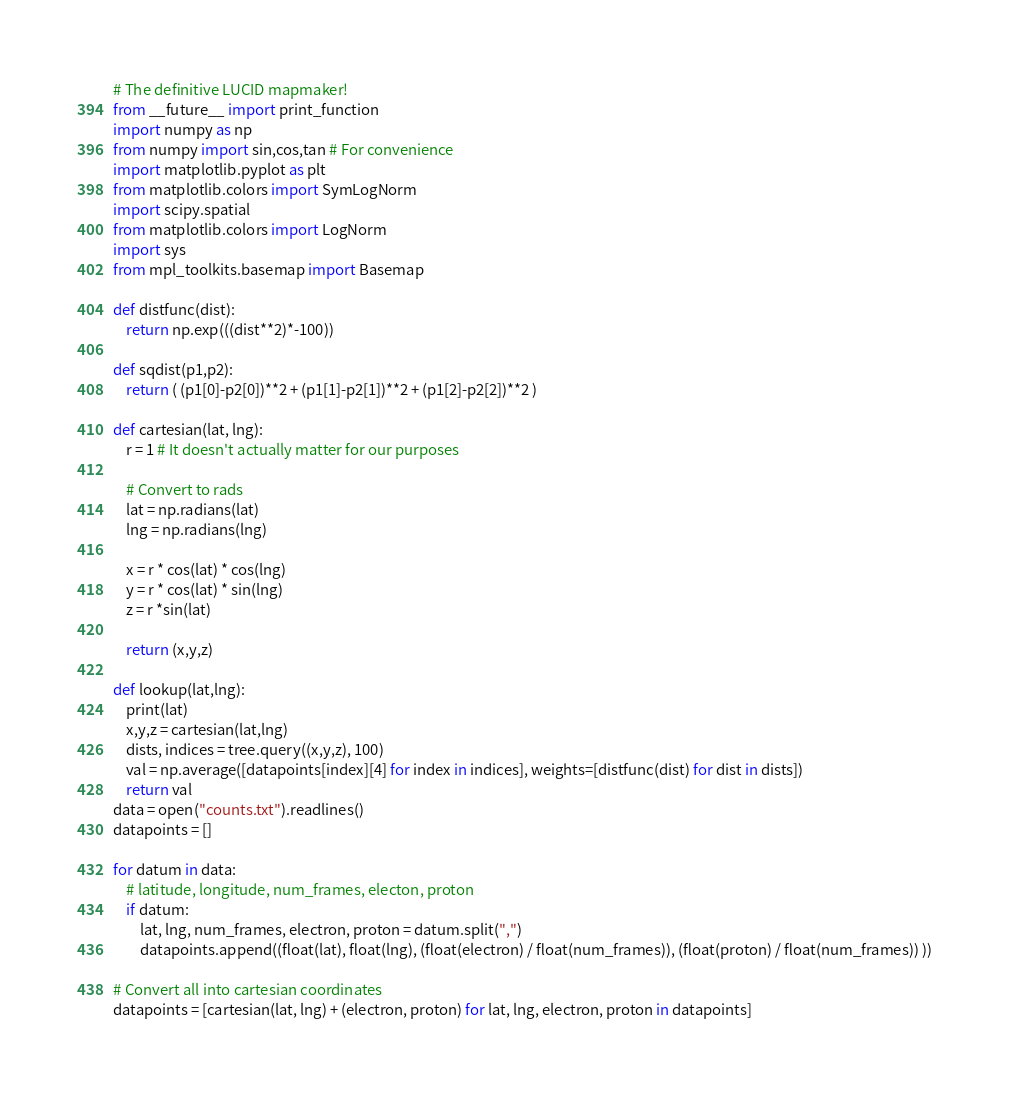<code> <loc_0><loc_0><loc_500><loc_500><_Python_># The definitive LUCID mapmaker!
from __future__ import print_function
import numpy as np
from numpy import sin,cos,tan # For convenience
import matplotlib.pyplot as plt
from matplotlib.colors import SymLogNorm
import scipy.spatial
from matplotlib.colors import LogNorm
import sys
from mpl_toolkits.basemap import Basemap

def distfunc(dist):
    return np.exp(((dist**2)*-100))

def sqdist(p1,p2):
    return ( (p1[0]-p2[0])**2 + (p1[1]-p2[1])**2 + (p1[2]-p2[2])**2 )

def cartesian(lat, lng):
    r = 1 # It doesn't actually matter for our purposes

    # Convert to rads
    lat = np.radians(lat)
    lng = np.radians(lng)

    x = r * cos(lat) * cos(lng)
    y = r * cos(lat) * sin(lng)
    z = r *sin(lat)

    return (x,y,z)

def lookup(lat,lng):
    print(lat)
    x,y,z = cartesian(lat,lng)
    dists, indices = tree.query((x,y,z), 100)
    val = np.average([datapoints[index][4] for index in indices], weights=[distfunc(dist) for dist in dists])
    return val
data = open("counts.txt").readlines()
datapoints = []

for datum in data:
    # latitude, longitude, num_frames, electon, proton
    if datum:
        lat, lng, num_frames, electron, proton = datum.split(",")
        datapoints.append((float(lat), float(lng), (float(electron) / float(num_frames)), (float(proton) / float(num_frames)) ))

# Convert all into cartesian coordinates
datapoints = [cartesian(lat, lng) + (electron, proton) for lat, lng, electron, proton in datapoints]
</code> 